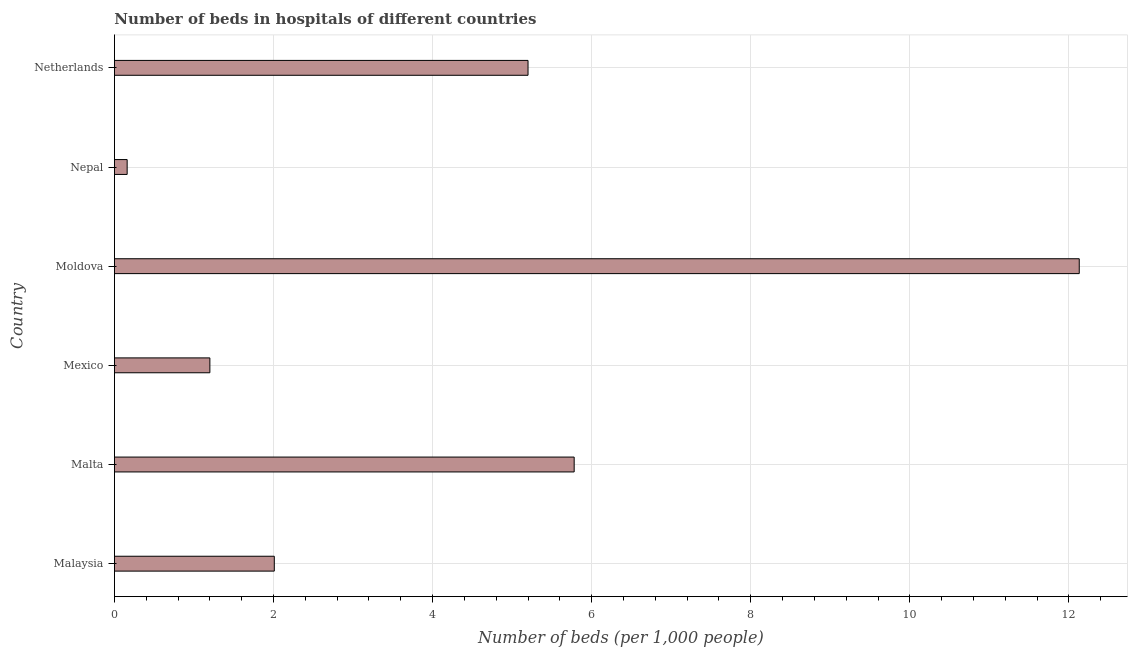Does the graph contain grids?
Your answer should be very brief. Yes. What is the title of the graph?
Ensure brevity in your answer.  Number of beds in hospitals of different countries. What is the label or title of the X-axis?
Make the answer very short. Number of beds (per 1,0 people). What is the label or title of the Y-axis?
Your answer should be very brief. Country. What is the number of hospital beds in Mexico?
Provide a short and direct response. 1.2. Across all countries, what is the maximum number of hospital beds?
Your answer should be very brief. 12.13. Across all countries, what is the minimum number of hospital beds?
Offer a terse response. 0.16. In which country was the number of hospital beds maximum?
Offer a terse response. Moldova. In which country was the number of hospital beds minimum?
Your answer should be compact. Nepal. What is the sum of the number of hospital beds?
Offer a terse response. 26.48. What is the difference between the number of hospital beds in Mexico and Netherlands?
Provide a short and direct response. -4. What is the average number of hospital beds per country?
Your answer should be very brief. 4.41. What is the median number of hospital beds?
Ensure brevity in your answer.  3.6. In how many countries, is the number of hospital beds greater than 6 %?
Make the answer very short. 1. What is the ratio of the number of hospital beds in Mexico to that in Moldova?
Your answer should be very brief. 0.1. Is the number of hospital beds in Nepal less than that in Netherlands?
Ensure brevity in your answer.  Yes. Is the difference between the number of hospital beds in Mexico and Nepal greater than the difference between any two countries?
Provide a short and direct response. No. What is the difference between the highest and the second highest number of hospital beds?
Give a very brief answer. 6.35. What is the difference between the highest and the lowest number of hospital beds?
Your response must be concise. 11.97. Are all the bars in the graph horizontal?
Ensure brevity in your answer.  Yes. Are the values on the major ticks of X-axis written in scientific E-notation?
Your response must be concise. No. What is the Number of beds (per 1,000 people) in Malaysia?
Your response must be concise. 2.01. What is the Number of beds (per 1,000 people) in Malta?
Keep it short and to the point. 5.78. What is the Number of beds (per 1,000 people) of Mexico?
Give a very brief answer. 1.2. What is the Number of beds (per 1,000 people) in Moldova?
Provide a short and direct response. 12.13. What is the Number of beds (per 1,000 people) of Nepal?
Make the answer very short. 0.16. What is the Number of beds (per 1,000 people) of Netherlands?
Provide a succinct answer. 5.2. What is the difference between the Number of beds (per 1,000 people) in Malaysia and Malta?
Your answer should be very brief. -3.77. What is the difference between the Number of beds (per 1,000 people) in Malaysia and Mexico?
Give a very brief answer. 0.81. What is the difference between the Number of beds (per 1,000 people) in Malaysia and Moldova?
Your answer should be very brief. -10.12. What is the difference between the Number of beds (per 1,000 people) in Malaysia and Nepal?
Provide a short and direct response. 1.85. What is the difference between the Number of beds (per 1,000 people) in Malaysia and Netherlands?
Your answer should be very brief. -3.19. What is the difference between the Number of beds (per 1,000 people) in Malta and Mexico?
Keep it short and to the point. 4.58. What is the difference between the Number of beds (per 1,000 people) in Malta and Moldova?
Your answer should be very brief. -6.35. What is the difference between the Number of beds (per 1,000 people) in Malta and Nepal?
Keep it short and to the point. 5.62. What is the difference between the Number of beds (per 1,000 people) in Malta and Netherlands?
Ensure brevity in your answer.  0.58. What is the difference between the Number of beds (per 1,000 people) in Mexico and Moldova?
Your answer should be compact. -10.93. What is the difference between the Number of beds (per 1,000 people) in Mexico and Nepal?
Offer a terse response. 1.04. What is the difference between the Number of beds (per 1,000 people) in Moldova and Nepal?
Your answer should be very brief. 11.97. What is the difference between the Number of beds (per 1,000 people) in Moldova and Netherlands?
Offer a very short reply. 6.93. What is the difference between the Number of beds (per 1,000 people) in Nepal and Netherlands?
Provide a short and direct response. -5.04. What is the ratio of the Number of beds (per 1,000 people) in Malaysia to that in Malta?
Make the answer very short. 0.35. What is the ratio of the Number of beds (per 1,000 people) in Malaysia to that in Mexico?
Your answer should be compact. 1.68. What is the ratio of the Number of beds (per 1,000 people) in Malaysia to that in Moldova?
Your response must be concise. 0.17. What is the ratio of the Number of beds (per 1,000 people) in Malaysia to that in Nepal?
Provide a short and direct response. 12.56. What is the ratio of the Number of beds (per 1,000 people) in Malaysia to that in Netherlands?
Make the answer very short. 0.39. What is the ratio of the Number of beds (per 1,000 people) in Malta to that in Mexico?
Provide a succinct answer. 4.82. What is the ratio of the Number of beds (per 1,000 people) in Malta to that in Moldova?
Give a very brief answer. 0.48. What is the ratio of the Number of beds (per 1,000 people) in Malta to that in Nepal?
Give a very brief answer. 36.12. What is the ratio of the Number of beds (per 1,000 people) in Malta to that in Netherlands?
Provide a short and direct response. 1.11. What is the ratio of the Number of beds (per 1,000 people) in Mexico to that in Moldova?
Ensure brevity in your answer.  0.1. What is the ratio of the Number of beds (per 1,000 people) in Mexico to that in Nepal?
Your answer should be compact. 7.5. What is the ratio of the Number of beds (per 1,000 people) in Mexico to that in Netherlands?
Provide a succinct answer. 0.23. What is the ratio of the Number of beds (per 1,000 people) in Moldova to that in Nepal?
Offer a very short reply. 75.81. What is the ratio of the Number of beds (per 1,000 people) in Moldova to that in Netherlands?
Offer a very short reply. 2.33. What is the ratio of the Number of beds (per 1,000 people) in Nepal to that in Netherlands?
Provide a succinct answer. 0.03. 